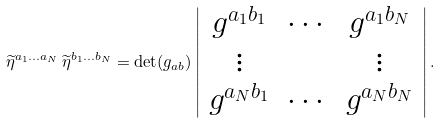Convert formula to latex. <formula><loc_0><loc_0><loc_500><loc_500>\widetilde { \eta } ^ { a _ { 1 } \dots a _ { N } } \, \widetilde { \eta } ^ { b _ { 1 } \dots b _ { N } } = \det ( g _ { a b } ) \left | \begin{array} { c c c } g ^ { a _ { 1 } b _ { 1 } } & \cdots & g ^ { a _ { 1 } b _ { N } } \\ \vdots & & \vdots \\ g ^ { a _ { N } b _ { 1 } } & \cdots & g ^ { a _ { N } b _ { N } } \end{array} \right | .</formula> 